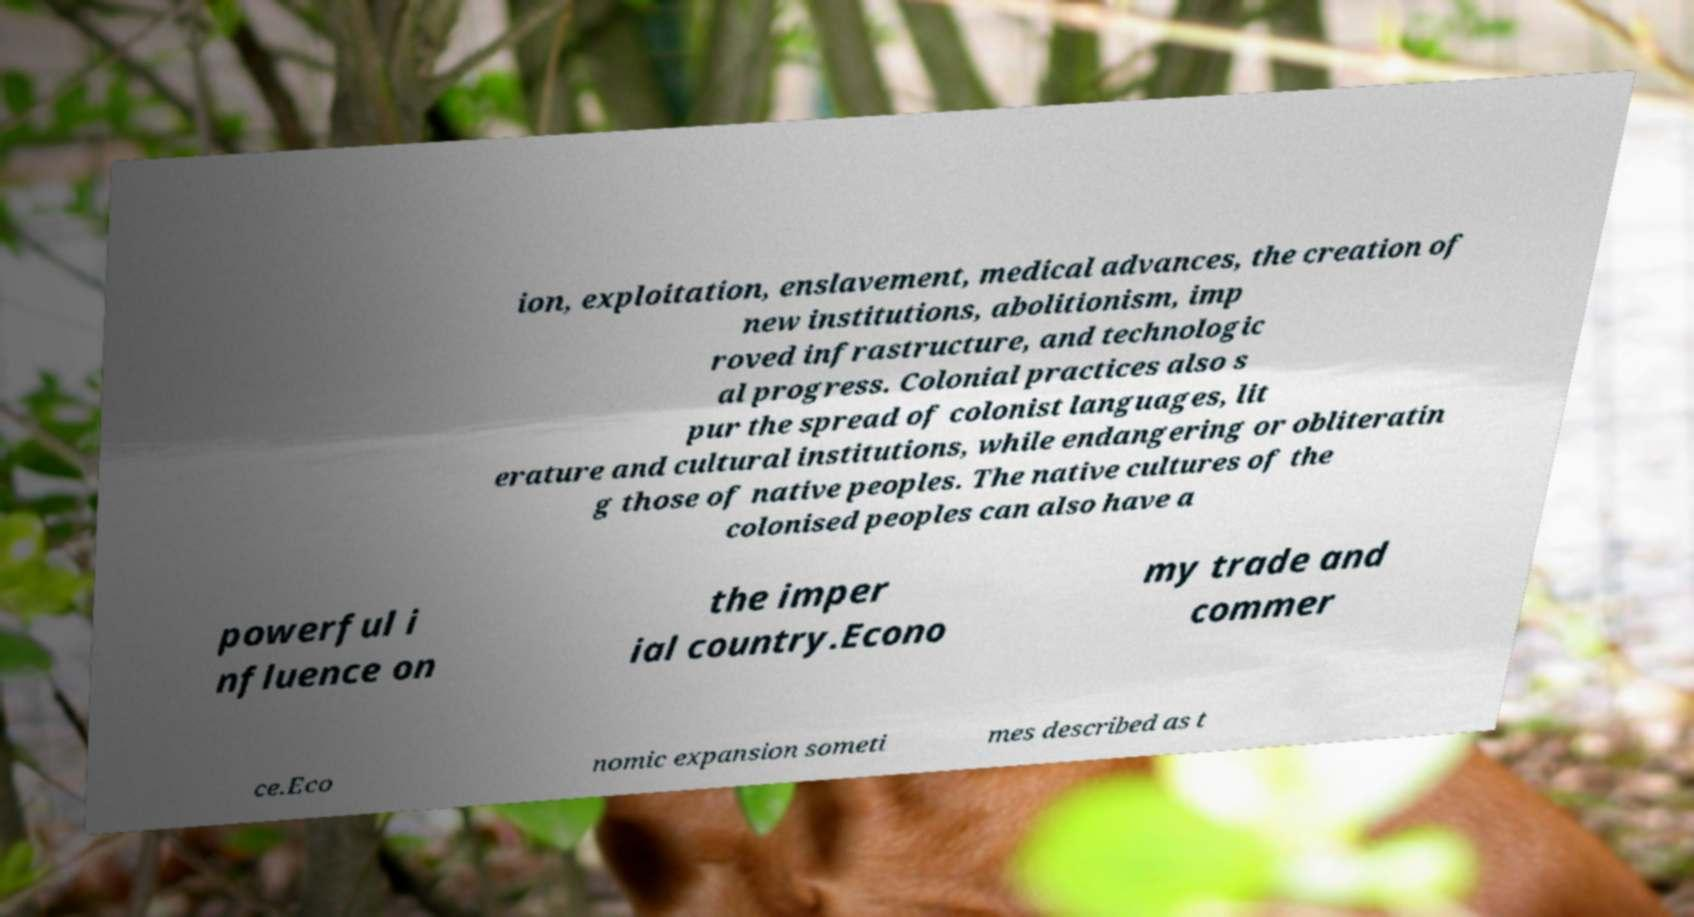Can you accurately transcribe the text from the provided image for me? ion, exploitation, enslavement, medical advances, the creation of new institutions, abolitionism, imp roved infrastructure, and technologic al progress. Colonial practices also s pur the spread of colonist languages, lit erature and cultural institutions, while endangering or obliteratin g those of native peoples. The native cultures of the colonised peoples can also have a powerful i nfluence on the imper ial country.Econo my trade and commer ce.Eco nomic expansion someti mes described as t 